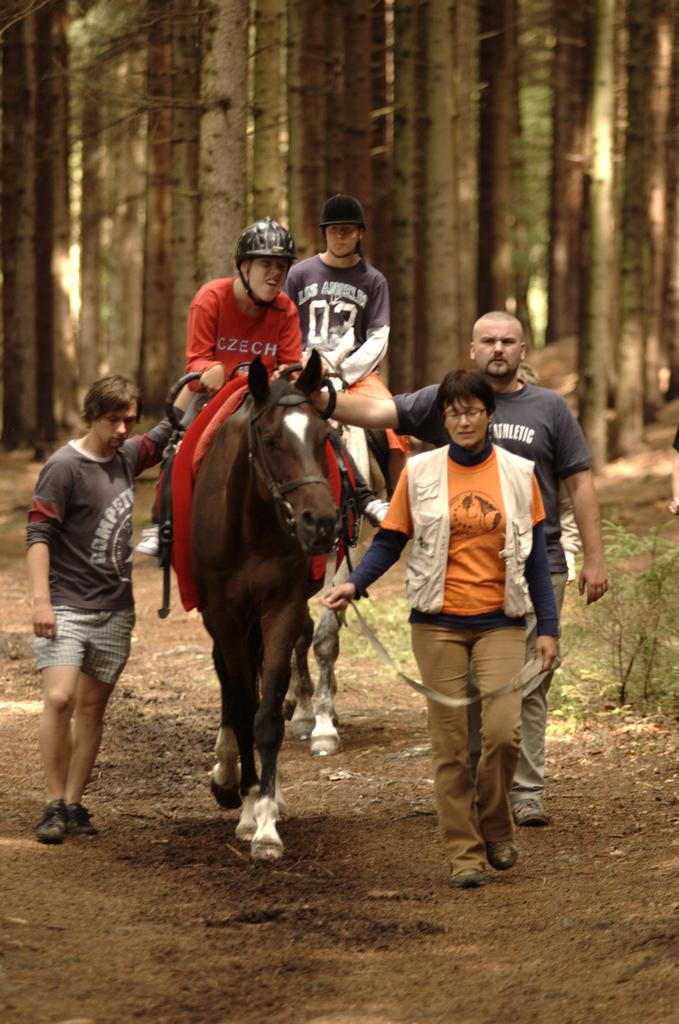What is happening in the image involving a horse? There are people walking with a horse in the image, and two persons are sitting on the horse. What safety precautions are being taken by the persons on the horse? The persons on the horse are wearing helmets. What can be seen in the background of the image? There are trees visible in the background of the image. What type of toy can be seen being twisted in the image? There is no toy present in the image, and no twisting action is taking place. 